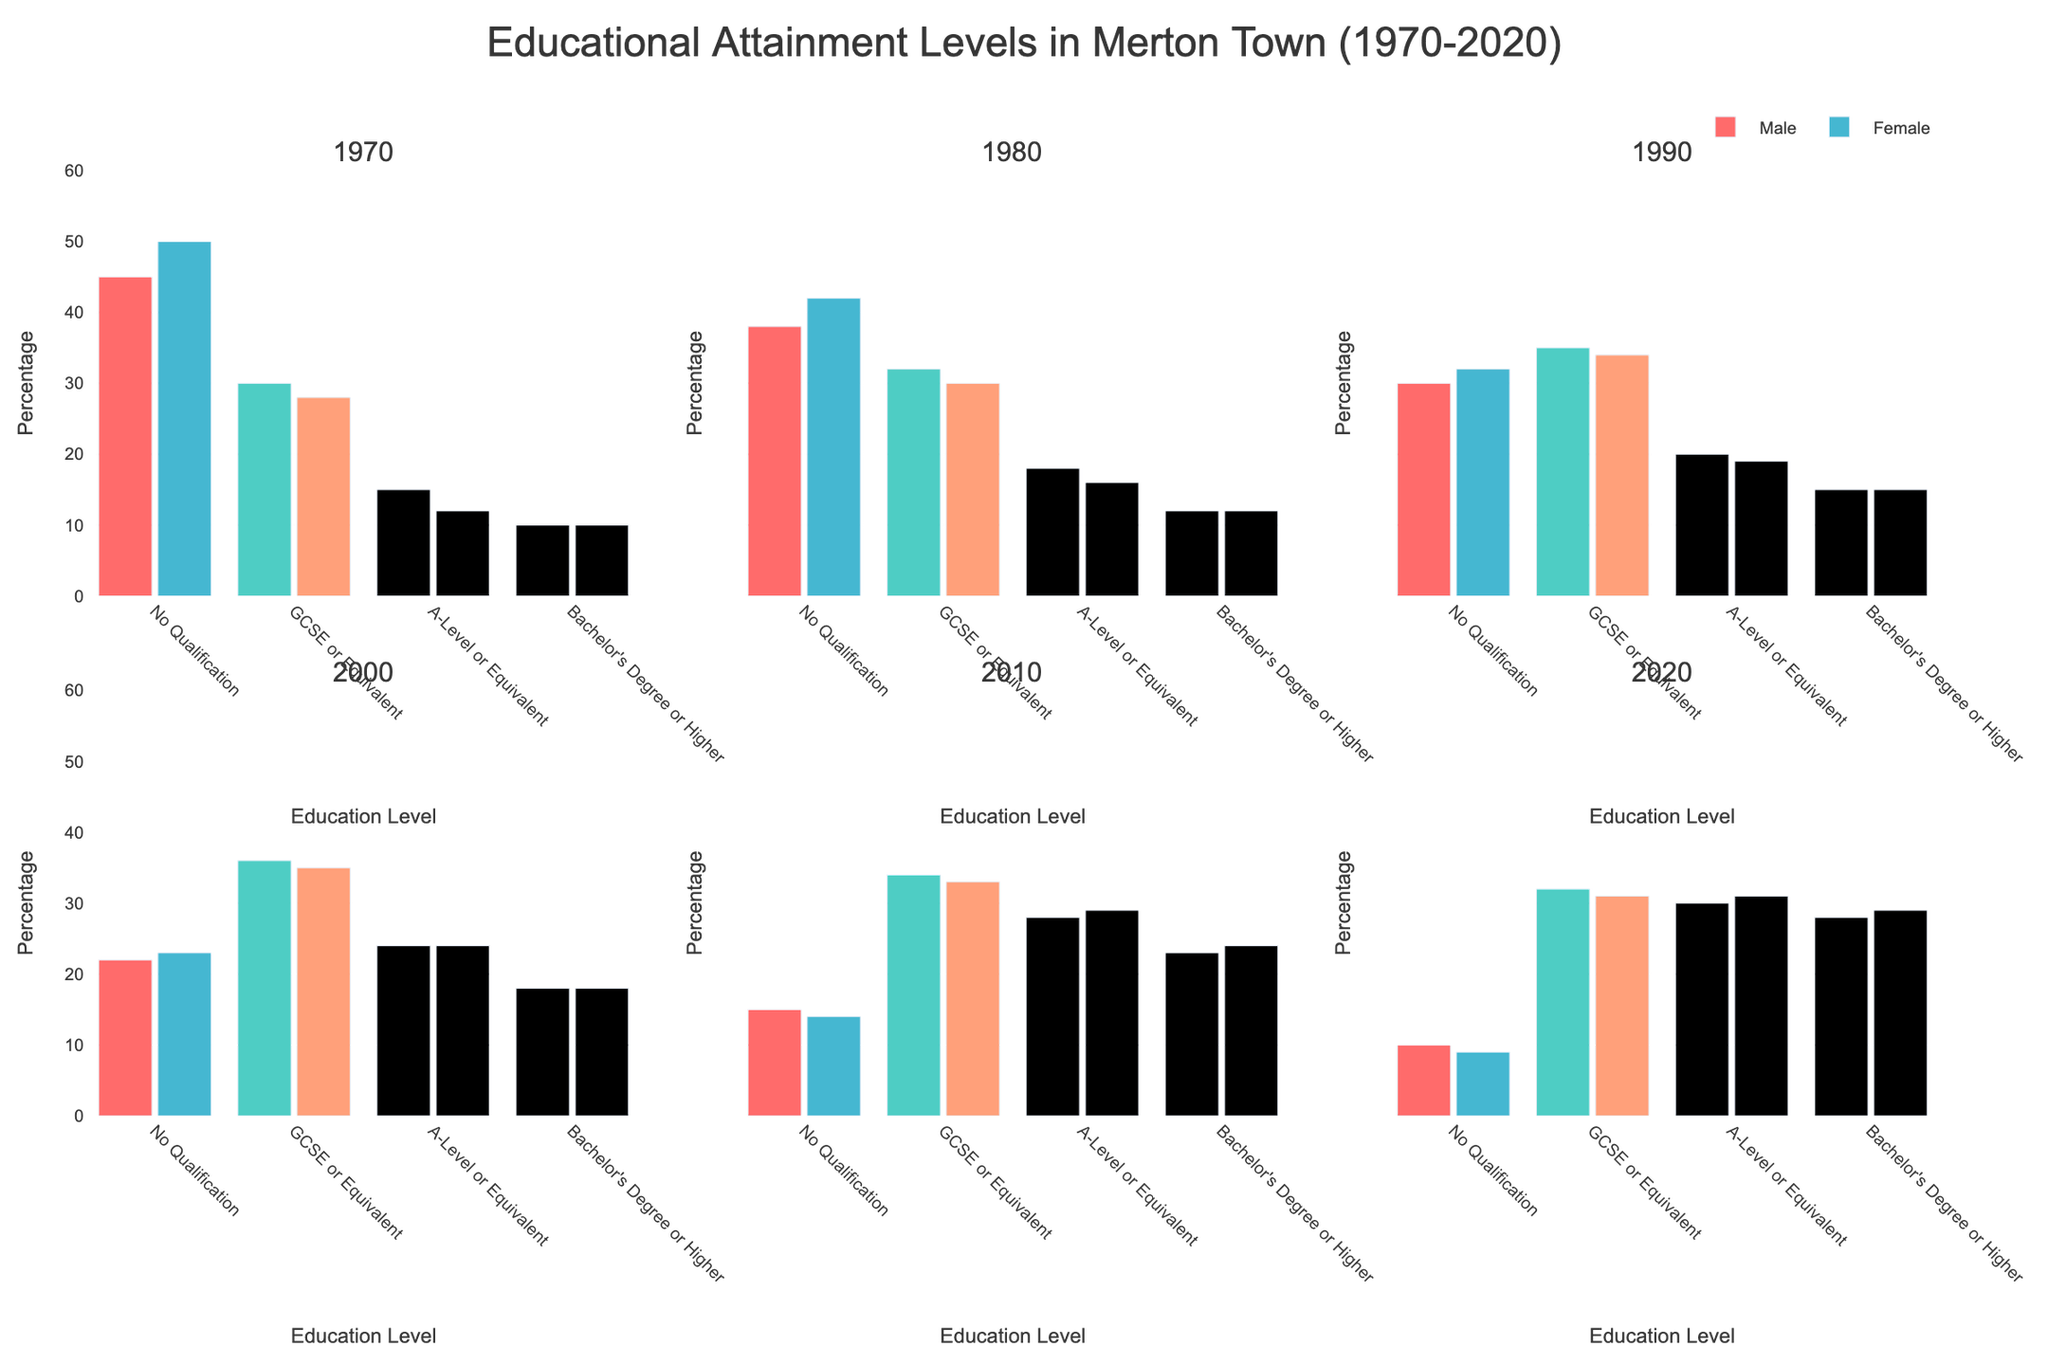What's the trend in the percentage of males with no qualifications from 1970 to 2020? Start by looking at the percentage value for males with no qualifications in each subplot: 1970 (45), 1980 (38), 1990 (30), 2000 (22), 2010 (15), 2020 (10). The trend shows a consistent decrease over the decades.
Answer: A consistent decrease In which year did women have the highest percentage of individuals with Bachelor's Degree or higher? Examine the subplots for the percentages of females with Bachelor's Degree or higher: 1970 (10), 1980 (12), 1990 (15), 2000 (18), 2010 (24), 2020 (29). The highest value is in 2020.
Answer: 2020 How does the percentage of males with GCSE or Equivalent in 2020 compare to the percentage in 1970? Look at the values for males with GCSE or Equivalent in 1970 (30) and 2020 (32). The percentage is higher in 2020.
Answer: Higher in 2020 What is the overall trend in educational attainment for females from 1970 to 2020 for those with A-level or Equivalent? Identify the percentages of females with A-level or Equivalent over the years: 1970 (12), 1980 (16), 1990 (19), 2000 (24), 2010 (29), 2020 (31). The trend shows a consistent increase over the decades.
Answer: A consistent increase Which gender had a higher percentage of individuals with no qualifications in 1970? Compare the percentages of males (45) and females (50) with no qualifications in 1970. Females had a higher percentage.
Answer: Females What's the difference in percentage between males and females with A-level or Equivalent in 2000? Locate the values for both males (24) and females (24) with A-level or Equivalent in 2000. The difference is 24 - 24 = 0.
Answer: 0 In which year is the gender gap smallest for individuals with Bachelor's Degree or higher? Analyze the gap between males and females in each year for Bachelor's Degree or higher: 1970 (0), 1980 (0), 1990 (0), 2000 (0), 2010 (-1), 2020 (-1). The smallest gap is 0, which occurs in multiple years: 1970, 1980, 1990, 2000.
Answer: Multiple years: 1970, 1980, 1990, 2000 How did the percentage of females with no qualifications change between 2000 and 2020? Examine the values for females with no qualifications in 2000 (23) and 2020 (9). The change is a decrease of 23 - 9 = 14 percentage points.
Answer: Decreased by 14 percentage points What's the mean percentage of females with GCSE or Equivalent across all years shown? Calculate the mean of the percentage values for females with GCSE or Equivalent: (28 + 30 + 34 + 35 + 33 + 31) / 6 = 32. Note that the percentages add up to 191, and there are 6 data points. Thus, the mean is 191 / 6 ≈ 31.83.
Answer: 31.83 Which year shows the closest percentage between males and females for those with A-level or Equivalent? Compare the differences for each year for males and females with A-level or Equivalent: 1970 (3), 1980 (2), 1990 (1), 2000 (0), 2010 (1), 2020 (1). The closest percentage is in 2000, with a difference of 0.
Answer: 2000 